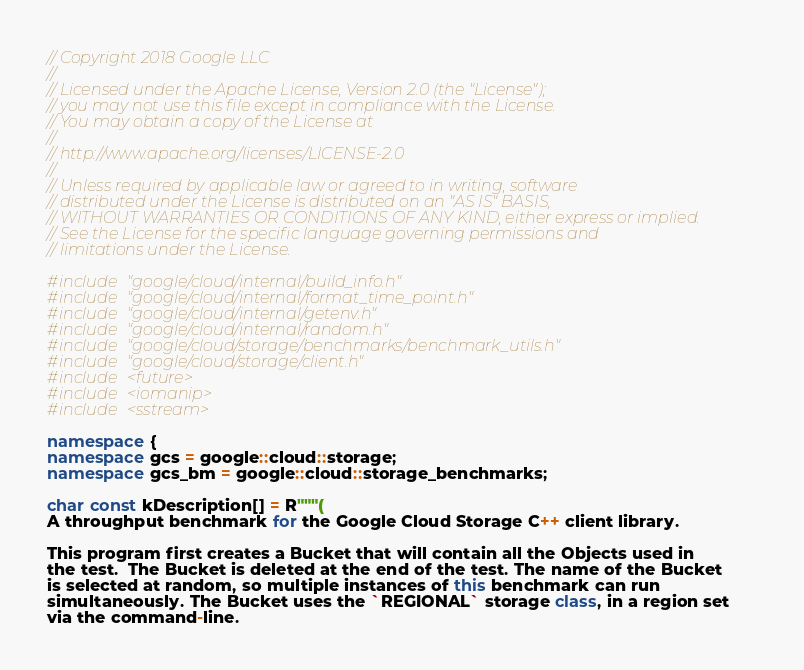Convert code to text. <code><loc_0><loc_0><loc_500><loc_500><_C++_>// Copyright 2018 Google LLC
//
// Licensed under the Apache License, Version 2.0 (the "License");
// you may not use this file except in compliance with the License.
// You may obtain a copy of the License at
//
// http://www.apache.org/licenses/LICENSE-2.0
//
// Unless required by applicable law or agreed to in writing, software
// distributed under the License is distributed on an "AS IS" BASIS,
// WITHOUT WARRANTIES OR CONDITIONS OF ANY KIND, either express or implied.
// See the License for the specific language governing permissions and
// limitations under the License.

#include "google/cloud/internal/build_info.h"
#include "google/cloud/internal/format_time_point.h"
#include "google/cloud/internal/getenv.h"
#include "google/cloud/internal/random.h"
#include "google/cloud/storage/benchmarks/benchmark_utils.h"
#include "google/cloud/storage/client.h"
#include <future>
#include <iomanip>
#include <sstream>

namespace {
namespace gcs = google::cloud::storage;
namespace gcs_bm = google::cloud::storage_benchmarks;

char const kDescription[] = R"""(
A throughput benchmark for the Google Cloud Storage C++ client library.

This program first creates a Bucket that will contain all the Objects used in
the test.  The Bucket is deleted at the end of the test. The name of the Bucket
is selected at random, so multiple instances of this benchmark can run
simultaneously. The Bucket uses the `REGIONAL` storage class, in a region set
via the command-line.
</code> 